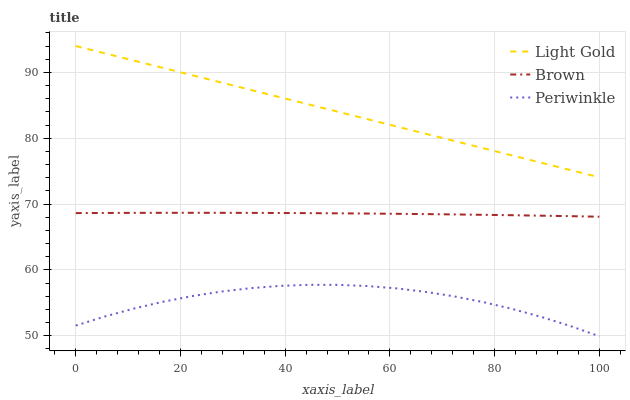Does Periwinkle have the minimum area under the curve?
Answer yes or no. Yes. Does Light Gold have the maximum area under the curve?
Answer yes or no. Yes. Does Light Gold have the minimum area under the curve?
Answer yes or no. No. Does Periwinkle have the maximum area under the curve?
Answer yes or no. No. Is Light Gold the smoothest?
Answer yes or no. Yes. Is Periwinkle the roughest?
Answer yes or no. Yes. Is Periwinkle the smoothest?
Answer yes or no. No. Is Light Gold the roughest?
Answer yes or no. No. Does Light Gold have the lowest value?
Answer yes or no. No. Does Periwinkle have the highest value?
Answer yes or no. No. Is Periwinkle less than Light Gold?
Answer yes or no. Yes. Is Light Gold greater than Periwinkle?
Answer yes or no. Yes. Does Periwinkle intersect Light Gold?
Answer yes or no. No. 